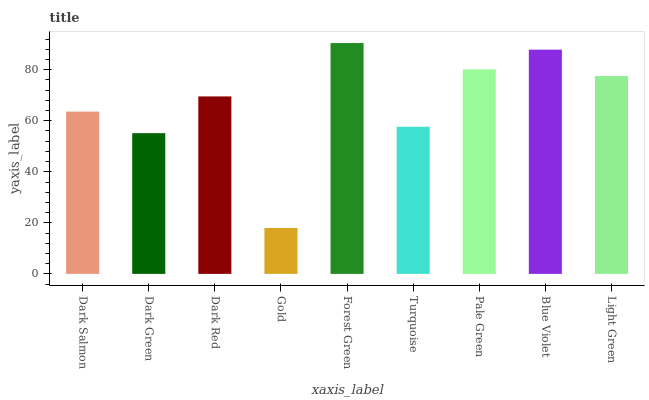Is Gold the minimum?
Answer yes or no. Yes. Is Forest Green the maximum?
Answer yes or no. Yes. Is Dark Green the minimum?
Answer yes or no. No. Is Dark Green the maximum?
Answer yes or no. No. Is Dark Salmon greater than Dark Green?
Answer yes or no. Yes. Is Dark Green less than Dark Salmon?
Answer yes or no. Yes. Is Dark Green greater than Dark Salmon?
Answer yes or no. No. Is Dark Salmon less than Dark Green?
Answer yes or no. No. Is Dark Red the high median?
Answer yes or no. Yes. Is Dark Red the low median?
Answer yes or no. Yes. Is Light Green the high median?
Answer yes or no. No. Is Gold the low median?
Answer yes or no. No. 